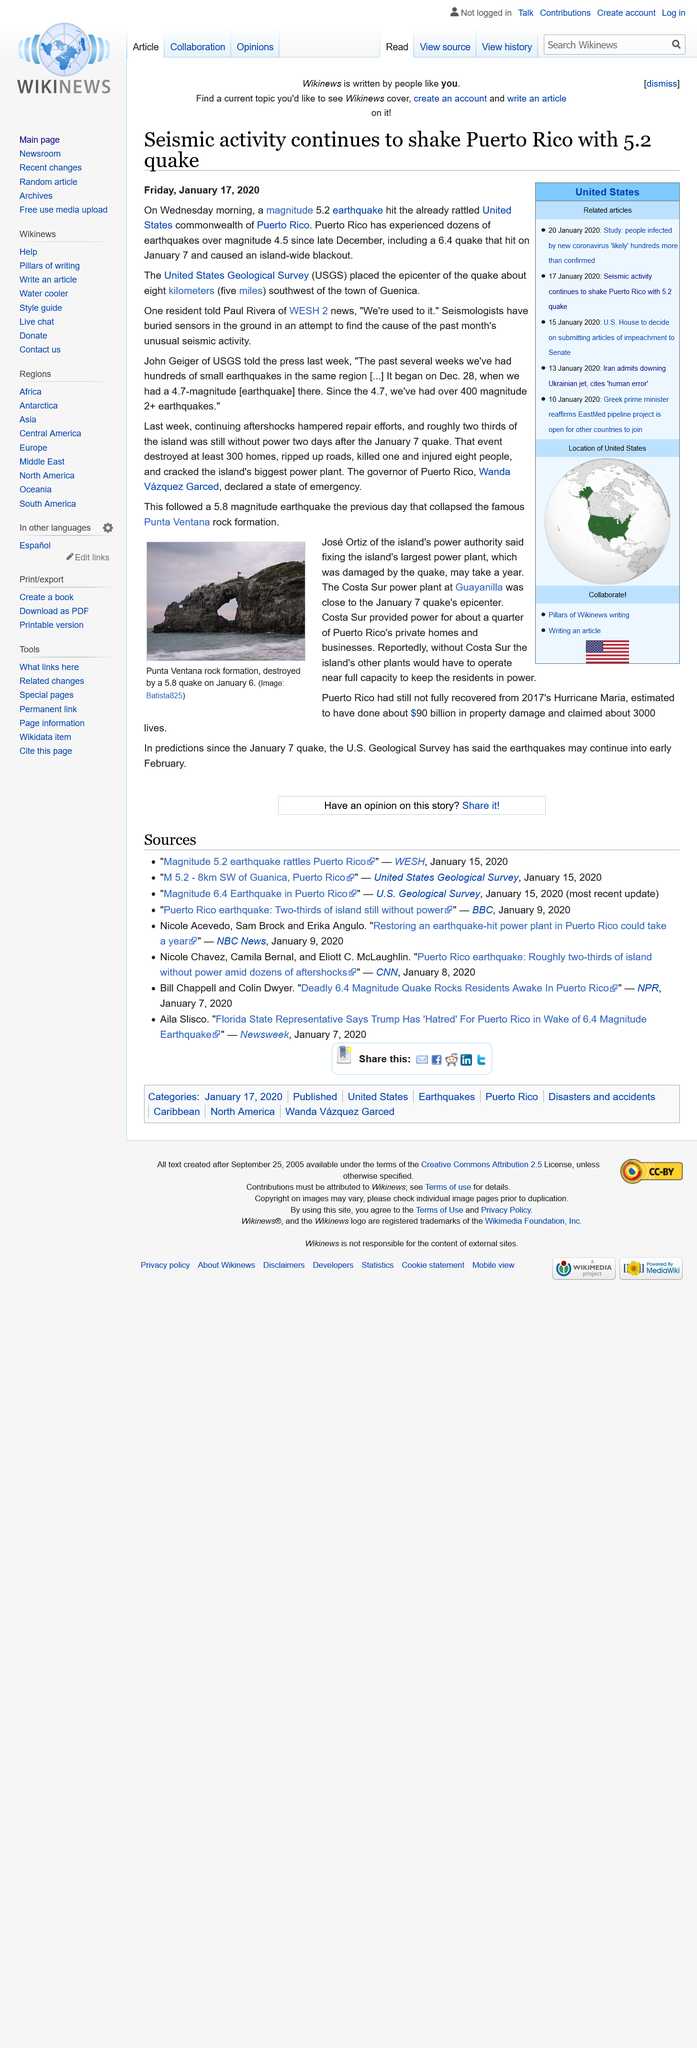Highlight a few significant elements in this photo. The Punta Ventana rock formation collapsed as a result of a significant earthquake with a magnitude of 5.8. Wanda Vázquez Garced is the governor of Puerto Rico. A 6.4 magnitude earthquake struck on January 7th, causing a blackout island-wide and significant damage. On January, a devastating earthquake struck Puerto Rico, causing widespread destruction. At least 300 homes were destroyed, and roads were severely damaged. The Punta Ventana rock formation collapsed, and the Costa Sur powerplant was severely damaged. The earthquake had a severe impact on the island, leaving a trail of destruction and disruption. On Wednesday morning, a magnitude 5.2 earthquake struck Puerto Rico, causing widespread destruction and rattling the United States commonwealth. 